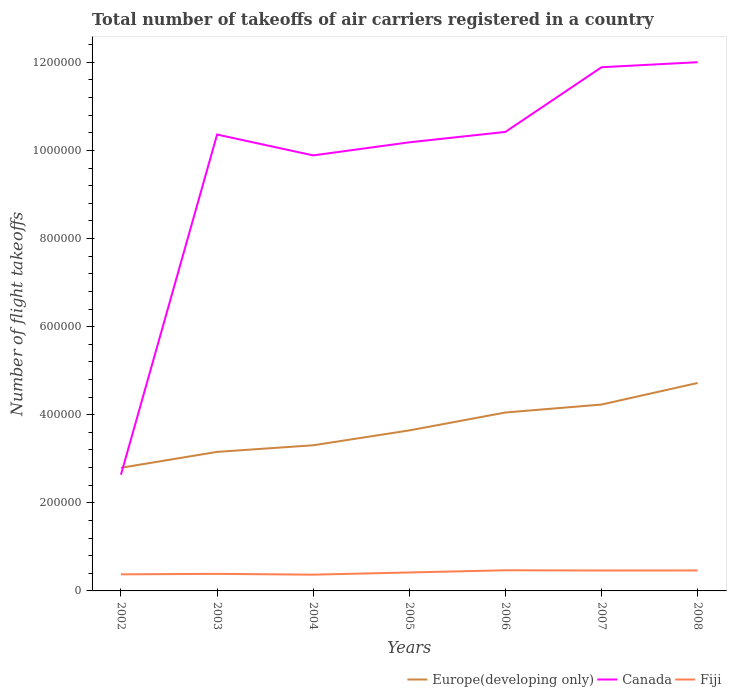How many different coloured lines are there?
Offer a terse response. 3. Is the number of lines equal to the number of legend labels?
Keep it short and to the point. Yes. Across all years, what is the maximum total number of flight takeoffs in Europe(developing only)?
Provide a short and direct response. 2.80e+05. In which year was the total number of flight takeoffs in Europe(developing only) maximum?
Ensure brevity in your answer.  2002. What is the total total number of flight takeoffs in Canada in the graph?
Provide a succinct answer. -1.82e+05. What is the difference between the highest and the second highest total number of flight takeoffs in Europe(developing only)?
Your answer should be very brief. 1.93e+05. What is the difference between the highest and the lowest total number of flight takeoffs in Fiji?
Your answer should be compact. 3. Is the total number of flight takeoffs in Canada strictly greater than the total number of flight takeoffs in Fiji over the years?
Provide a succinct answer. No. What is the difference between two consecutive major ticks on the Y-axis?
Make the answer very short. 2.00e+05. Are the values on the major ticks of Y-axis written in scientific E-notation?
Keep it short and to the point. No. Where does the legend appear in the graph?
Offer a very short reply. Bottom right. What is the title of the graph?
Give a very brief answer. Total number of takeoffs of air carriers registered in a country. Does "Congo (Democratic)" appear as one of the legend labels in the graph?
Offer a very short reply. No. What is the label or title of the Y-axis?
Provide a short and direct response. Number of flight takeoffs. What is the Number of flight takeoffs of Europe(developing only) in 2002?
Your answer should be very brief. 2.80e+05. What is the Number of flight takeoffs in Canada in 2002?
Ensure brevity in your answer.  2.64e+05. What is the Number of flight takeoffs in Fiji in 2002?
Provide a succinct answer. 3.77e+04. What is the Number of flight takeoffs of Europe(developing only) in 2003?
Provide a succinct answer. 3.16e+05. What is the Number of flight takeoffs of Canada in 2003?
Your answer should be compact. 1.04e+06. What is the Number of flight takeoffs of Fiji in 2003?
Your answer should be compact. 3.87e+04. What is the Number of flight takeoffs in Europe(developing only) in 2004?
Keep it short and to the point. 3.31e+05. What is the Number of flight takeoffs in Canada in 2004?
Keep it short and to the point. 9.89e+05. What is the Number of flight takeoffs in Fiji in 2004?
Provide a succinct answer. 3.69e+04. What is the Number of flight takeoffs in Europe(developing only) in 2005?
Keep it short and to the point. 3.64e+05. What is the Number of flight takeoffs of Canada in 2005?
Make the answer very short. 1.02e+06. What is the Number of flight takeoffs of Fiji in 2005?
Your response must be concise. 4.19e+04. What is the Number of flight takeoffs in Europe(developing only) in 2006?
Offer a terse response. 4.05e+05. What is the Number of flight takeoffs of Canada in 2006?
Make the answer very short. 1.04e+06. What is the Number of flight takeoffs in Fiji in 2006?
Provide a short and direct response. 4.69e+04. What is the Number of flight takeoffs of Europe(developing only) in 2007?
Give a very brief answer. 4.23e+05. What is the Number of flight takeoffs of Canada in 2007?
Your answer should be very brief. 1.19e+06. What is the Number of flight takeoffs of Fiji in 2007?
Your answer should be very brief. 4.64e+04. What is the Number of flight takeoffs in Europe(developing only) in 2008?
Keep it short and to the point. 4.72e+05. What is the Number of flight takeoffs in Canada in 2008?
Provide a short and direct response. 1.20e+06. What is the Number of flight takeoffs of Fiji in 2008?
Offer a very short reply. 4.65e+04. Across all years, what is the maximum Number of flight takeoffs in Europe(developing only)?
Offer a very short reply. 4.72e+05. Across all years, what is the maximum Number of flight takeoffs of Canada?
Your answer should be compact. 1.20e+06. Across all years, what is the maximum Number of flight takeoffs of Fiji?
Make the answer very short. 4.69e+04. Across all years, what is the minimum Number of flight takeoffs of Europe(developing only)?
Give a very brief answer. 2.80e+05. Across all years, what is the minimum Number of flight takeoffs in Canada?
Make the answer very short. 2.64e+05. Across all years, what is the minimum Number of flight takeoffs in Fiji?
Offer a very short reply. 3.69e+04. What is the total Number of flight takeoffs of Europe(developing only) in the graph?
Ensure brevity in your answer.  2.59e+06. What is the total Number of flight takeoffs in Canada in the graph?
Provide a short and direct response. 6.74e+06. What is the total Number of flight takeoffs in Fiji in the graph?
Give a very brief answer. 2.95e+05. What is the difference between the Number of flight takeoffs in Europe(developing only) in 2002 and that in 2003?
Keep it short and to the point. -3.61e+04. What is the difference between the Number of flight takeoffs of Canada in 2002 and that in 2003?
Your answer should be very brief. -7.72e+05. What is the difference between the Number of flight takeoffs in Fiji in 2002 and that in 2003?
Offer a very short reply. -1047. What is the difference between the Number of flight takeoffs of Europe(developing only) in 2002 and that in 2004?
Give a very brief answer. -5.11e+04. What is the difference between the Number of flight takeoffs of Canada in 2002 and that in 2004?
Offer a terse response. -7.25e+05. What is the difference between the Number of flight takeoffs in Fiji in 2002 and that in 2004?
Keep it short and to the point. 765. What is the difference between the Number of flight takeoffs of Europe(developing only) in 2002 and that in 2005?
Your answer should be compact. -8.49e+04. What is the difference between the Number of flight takeoffs in Canada in 2002 and that in 2005?
Offer a terse response. -7.55e+05. What is the difference between the Number of flight takeoffs of Fiji in 2002 and that in 2005?
Provide a succinct answer. -4201. What is the difference between the Number of flight takeoffs of Europe(developing only) in 2002 and that in 2006?
Provide a succinct answer. -1.26e+05. What is the difference between the Number of flight takeoffs of Canada in 2002 and that in 2006?
Provide a short and direct response. -7.78e+05. What is the difference between the Number of flight takeoffs in Fiji in 2002 and that in 2006?
Provide a short and direct response. -9181. What is the difference between the Number of flight takeoffs in Europe(developing only) in 2002 and that in 2007?
Provide a short and direct response. -1.44e+05. What is the difference between the Number of flight takeoffs of Canada in 2002 and that in 2007?
Offer a very short reply. -9.25e+05. What is the difference between the Number of flight takeoffs in Fiji in 2002 and that in 2007?
Make the answer very short. -8674. What is the difference between the Number of flight takeoffs of Europe(developing only) in 2002 and that in 2008?
Your answer should be very brief. -1.93e+05. What is the difference between the Number of flight takeoffs in Canada in 2002 and that in 2008?
Give a very brief answer. -9.36e+05. What is the difference between the Number of flight takeoffs of Fiji in 2002 and that in 2008?
Your answer should be very brief. -8782. What is the difference between the Number of flight takeoffs in Europe(developing only) in 2003 and that in 2004?
Offer a terse response. -1.50e+04. What is the difference between the Number of flight takeoffs in Canada in 2003 and that in 2004?
Offer a very short reply. 4.73e+04. What is the difference between the Number of flight takeoffs of Fiji in 2003 and that in 2004?
Your answer should be compact. 1812. What is the difference between the Number of flight takeoffs in Europe(developing only) in 2003 and that in 2005?
Make the answer very short. -4.87e+04. What is the difference between the Number of flight takeoffs of Canada in 2003 and that in 2005?
Provide a succinct answer. 1.76e+04. What is the difference between the Number of flight takeoffs of Fiji in 2003 and that in 2005?
Give a very brief answer. -3154. What is the difference between the Number of flight takeoffs in Europe(developing only) in 2003 and that in 2006?
Your response must be concise. -8.94e+04. What is the difference between the Number of flight takeoffs of Canada in 2003 and that in 2006?
Give a very brief answer. -6008. What is the difference between the Number of flight takeoffs in Fiji in 2003 and that in 2006?
Offer a very short reply. -8134. What is the difference between the Number of flight takeoffs of Europe(developing only) in 2003 and that in 2007?
Provide a short and direct response. -1.07e+05. What is the difference between the Number of flight takeoffs in Canada in 2003 and that in 2007?
Your response must be concise. -1.53e+05. What is the difference between the Number of flight takeoffs of Fiji in 2003 and that in 2007?
Offer a terse response. -7627. What is the difference between the Number of flight takeoffs in Europe(developing only) in 2003 and that in 2008?
Offer a terse response. -1.56e+05. What is the difference between the Number of flight takeoffs in Canada in 2003 and that in 2008?
Ensure brevity in your answer.  -1.64e+05. What is the difference between the Number of flight takeoffs in Fiji in 2003 and that in 2008?
Make the answer very short. -7735. What is the difference between the Number of flight takeoffs of Europe(developing only) in 2004 and that in 2005?
Make the answer very short. -3.38e+04. What is the difference between the Number of flight takeoffs in Canada in 2004 and that in 2005?
Make the answer very short. -2.97e+04. What is the difference between the Number of flight takeoffs of Fiji in 2004 and that in 2005?
Give a very brief answer. -4966. What is the difference between the Number of flight takeoffs of Europe(developing only) in 2004 and that in 2006?
Ensure brevity in your answer.  -7.44e+04. What is the difference between the Number of flight takeoffs of Canada in 2004 and that in 2006?
Offer a very short reply. -5.33e+04. What is the difference between the Number of flight takeoffs of Fiji in 2004 and that in 2006?
Offer a very short reply. -9946. What is the difference between the Number of flight takeoffs in Europe(developing only) in 2004 and that in 2007?
Your answer should be compact. -9.25e+04. What is the difference between the Number of flight takeoffs in Canada in 2004 and that in 2007?
Offer a very short reply. -2.00e+05. What is the difference between the Number of flight takeoffs of Fiji in 2004 and that in 2007?
Give a very brief answer. -9439. What is the difference between the Number of flight takeoffs of Europe(developing only) in 2004 and that in 2008?
Your answer should be compact. -1.41e+05. What is the difference between the Number of flight takeoffs in Canada in 2004 and that in 2008?
Your response must be concise. -2.12e+05. What is the difference between the Number of flight takeoffs of Fiji in 2004 and that in 2008?
Your response must be concise. -9547. What is the difference between the Number of flight takeoffs of Europe(developing only) in 2005 and that in 2006?
Provide a short and direct response. -4.07e+04. What is the difference between the Number of flight takeoffs in Canada in 2005 and that in 2006?
Provide a short and direct response. -2.36e+04. What is the difference between the Number of flight takeoffs in Fiji in 2005 and that in 2006?
Ensure brevity in your answer.  -4980. What is the difference between the Number of flight takeoffs of Europe(developing only) in 2005 and that in 2007?
Give a very brief answer. -5.87e+04. What is the difference between the Number of flight takeoffs of Canada in 2005 and that in 2007?
Your response must be concise. -1.70e+05. What is the difference between the Number of flight takeoffs of Fiji in 2005 and that in 2007?
Make the answer very short. -4473. What is the difference between the Number of flight takeoffs in Europe(developing only) in 2005 and that in 2008?
Ensure brevity in your answer.  -1.08e+05. What is the difference between the Number of flight takeoffs in Canada in 2005 and that in 2008?
Make the answer very short. -1.82e+05. What is the difference between the Number of flight takeoffs in Fiji in 2005 and that in 2008?
Keep it short and to the point. -4581. What is the difference between the Number of flight takeoffs of Europe(developing only) in 2006 and that in 2007?
Make the answer very short. -1.81e+04. What is the difference between the Number of flight takeoffs of Canada in 2006 and that in 2007?
Your answer should be compact. -1.47e+05. What is the difference between the Number of flight takeoffs of Fiji in 2006 and that in 2007?
Provide a short and direct response. 507. What is the difference between the Number of flight takeoffs in Europe(developing only) in 2006 and that in 2008?
Give a very brief answer. -6.70e+04. What is the difference between the Number of flight takeoffs of Canada in 2006 and that in 2008?
Provide a succinct answer. -1.58e+05. What is the difference between the Number of flight takeoffs in Fiji in 2006 and that in 2008?
Keep it short and to the point. 399. What is the difference between the Number of flight takeoffs of Europe(developing only) in 2007 and that in 2008?
Your response must be concise. -4.90e+04. What is the difference between the Number of flight takeoffs of Canada in 2007 and that in 2008?
Your answer should be compact. -1.14e+04. What is the difference between the Number of flight takeoffs in Fiji in 2007 and that in 2008?
Your answer should be compact. -108. What is the difference between the Number of flight takeoffs in Europe(developing only) in 2002 and the Number of flight takeoffs in Canada in 2003?
Your answer should be compact. -7.57e+05. What is the difference between the Number of flight takeoffs of Europe(developing only) in 2002 and the Number of flight takeoffs of Fiji in 2003?
Provide a short and direct response. 2.41e+05. What is the difference between the Number of flight takeoffs in Canada in 2002 and the Number of flight takeoffs in Fiji in 2003?
Offer a very short reply. 2.25e+05. What is the difference between the Number of flight takeoffs in Europe(developing only) in 2002 and the Number of flight takeoffs in Canada in 2004?
Provide a succinct answer. -7.09e+05. What is the difference between the Number of flight takeoffs of Europe(developing only) in 2002 and the Number of flight takeoffs of Fiji in 2004?
Your response must be concise. 2.43e+05. What is the difference between the Number of flight takeoffs in Canada in 2002 and the Number of flight takeoffs in Fiji in 2004?
Keep it short and to the point. 2.27e+05. What is the difference between the Number of flight takeoffs in Europe(developing only) in 2002 and the Number of flight takeoffs in Canada in 2005?
Your answer should be compact. -7.39e+05. What is the difference between the Number of flight takeoffs of Europe(developing only) in 2002 and the Number of flight takeoffs of Fiji in 2005?
Offer a very short reply. 2.38e+05. What is the difference between the Number of flight takeoffs of Canada in 2002 and the Number of flight takeoffs of Fiji in 2005?
Provide a succinct answer. 2.22e+05. What is the difference between the Number of flight takeoffs of Europe(developing only) in 2002 and the Number of flight takeoffs of Canada in 2006?
Your answer should be compact. -7.63e+05. What is the difference between the Number of flight takeoffs of Europe(developing only) in 2002 and the Number of flight takeoffs of Fiji in 2006?
Your answer should be compact. 2.33e+05. What is the difference between the Number of flight takeoffs in Canada in 2002 and the Number of flight takeoffs in Fiji in 2006?
Give a very brief answer. 2.17e+05. What is the difference between the Number of flight takeoffs in Europe(developing only) in 2002 and the Number of flight takeoffs in Canada in 2007?
Make the answer very short. -9.09e+05. What is the difference between the Number of flight takeoffs in Europe(developing only) in 2002 and the Number of flight takeoffs in Fiji in 2007?
Your answer should be compact. 2.33e+05. What is the difference between the Number of flight takeoffs of Canada in 2002 and the Number of flight takeoffs of Fiji in 2007?
Your response must be concise. 2.18e+05. What is the difference between the Number of flight takeoffs in Europe(developing only) in 2002 and the Number of flight takeoffs in Canada in 2008?
Keep it short and to the point. -9.21e+05. What is the difference between the Number of flight takeoffs of Europe(developing only) in 2002 and the Number of flight takeoffs of Fiji in 2008?
Offer a terse response. 2.33e+05. What is the difference between the Number of flight takeoffs of Canada in 2002 and the Number of flight takeoffs of Fiji in 2008?
Ensure brevity in your answer.  2.17e+05. What is the difference between the Number of flight takeoffs of Europe(developing only) in 2003 and the Number of flight takeoffs of Canada in 2004?
Give a very brief answer. -6.73e+05. What is the difference between the Number of flight takeoffs in Europe(developing only) in 2003 and the Number of flight takeoffs in Fiji in 2004?
Give a very brief answer. 2.79e+05. What is the difference between the Number of flight takeoffs in Canada in 2003 and the Number of flight takeoffs in Fiji in 2004?
Make the answer very short. 9.99e+05. What is the difference between the Number of flight takeoffs of Europe(developing only) in 2003 and the Number of flight takeoffs of Canada in 2005?
Provide a succinct answer. -7.03e+05. What is the difference between the Number of flight takeoffs of Europe(developing only) in 2003 and the Number of flight takeoffs of Fiji in 2005?
Your response must be concise. 2.74e+05. What is the difference between the Number of flight takeoffs in Canada in 2003 and the Number of flight takeoffs in Fiji in 2005?
Offer a terse response. 9.94e+05. What is the difference between the Number of flight takeoffs in Europe(developing only) in 2003 and the Number of flight takeoffs in Canada in 2006?
Your answer should be compact. -7.26e+05. What is the difference between the Number of flight takeoffs of Europe(developing only) in 2003 and the Number of flight takeoffs of Fiji in 2006?
Provide a short and direct response. 2.69e+05. What is the difference between the Number of flight takeoffs in Canada in 2003 and the Number of flight takeoffs in Fiji in 2006?
Ensure brevity in your answer.  9.89e+05. What is the difference between the Number of flight takeoffs of Europe(developing only) in 2003 and the Number of flight takeoffs of Canada in 2007?
Provide a short and direct response. -8.73e+05. What is the difference between the Number of flight takeoffs in Europe(developing only) in 2003 and the Number of flight takeoffs in Fiji in 2007?
Your response must be concise. 2.69e+05. What is the difference between the Number of flight takeoffs of Canada in 2003 and the Number of flight takeoffs of Fiji in 2007?
Your answer should be very brief. 9.90e+05. What is the difference between the Number of flight takeoffs of Europe(developing only) in 2003 and the Number of flight takeoffs of Canada in 2008?
Provide a succinct answer. -8.85e+05. What is the difference between the Number of flight takeoffs of Europe(developing only) in 2003 and the Number of flight takeoffs of Fiji in 2008?
Provide a short and direct response. 2.69e+05. What is the difference between the Number of flight takeoffs of Canada in 2003 and the Number of flight takeoffs of Fiji in 2008?
Give a very brief answer. 9.90e+05. What is the difference between the Number of flight takeoffs in Europe(developing only) in 2004 and the Number of flight takeoffs in Canada in 2005?
Make the answer very short. -6.88e+05. What is the difference between the Number of flight takeoffs of Europe(developing only) in 2004 and the Number of flight takeoffs of Fiji in 2005?
Provide a short and direct response. 2.89e+05. What is the difference between the Number of flight takeoffs of Canada in 2004 and the Number of flight takeoffs of Fiji in 2005?
Ensure brevity in your answer.  9.47e+05. What is the difference between the Number of flight takeoffs of Europe(developing only) in 2004 and the Number of flight takeoffs of Canada in 2006?
Give a very brief answer. -7.11e+05. What is the difference between the Number of flight takeoffs in Europe(developing only) in 2004 and the Number of flight takeoffs in Fiji in 2006?
Give a very brief answer. 2.84e+05. What is the difference between the Number of flight takeoffs of Canada in 2004 and the Number of flight takeoffs of Fiji in 2006?
Your answer should be very brief. 9.42e+05. What is the difference between the Number of flight takeoffs of Europe(developing only) in 2004 and the Number of flight takeoffs of Canada in 2007?
Provide a succinct answer. -8.58e+05. What is the difference between the Number of flight takeoffs of Europe(developing only) in 2004 and the Number of flight takeoffs of Fiji in 2007?
Offer a terse response. 2.84e+05. What is the difference between the Number of flight takeoffs of Canada in 2004 and the Number of flight takeoffs of Fiji in 2007?
Provide a succinct answer. 9.42e+05. What is the difference between the Number of flight takeoffs of Europe(developing only) in 2004 and the Number of flight takeoffs of Canada in 2008?
Ensure brevity in your answer.  -8.70e+05. What is the difference between the Number of flight takeoffs of Europe(developing only) in 2004 and the Number of flight takeoffs of Fiji in 2008?
Offer a terse response. 2.84e+05. What is the difference between the Number of flight takeoffs of Canada in 2004 and the Number of flight takeoffs of Fiji in 2008?
Your answer should be very brief. 9.42e+05. What is the difference between the Number of flight takeoffs in Europe(developing only) in 2005 and the Number of flight takeoffs in Canada in 2006?
Offer a very short reply. -6.78e+05. What is the difference between the Number of flight takeoffs in Europe(developing only) in 2005 and the Number of flight takeoffs in Fiji in 2006?
Offer a terse response. 3.18e+05. What is the difference between the Number of flight takeoffs of Canada in 2005 and the Number of flight takeoffs of Fiji in 2006?
Your answer should be very brief. 9.72e+05. What is the difference between the Number of flight takeoffs of Europe(developing only) in 2005 and the Number of flight takeoffs of Canada in 2007?
Offer a terse response. -8.25e+05. What is the difference between the Number of flight takeoffs of Europe(developing only) in 2005 and the Number of flight takeoffs of Fiji in 2007?
Ensure brevity in your answer.  3.18e+05. What is the difference between the Number of flight takeoffs of Canada in 2005 and the Number of flight takeoffs of Fiji in 2007?
Provide a short and direct response. 9.72e+05. What is the difference between the Number of flight takeoffs of Europe(developing only) in 2005 and the Number of flight takeoffs of Canada in 2008?
Your answer should be very brief. -8.36e+05. What is the difference between the Number of flight takeoffs of Europe(developing only) in 2005 and the Number of flight takeoffs of Fiji in 2008?
Your answer should be very brief. 3.18e+05. What is the difference between the Number of flight takeoffs in Canada in 2005 and the Number of flight takeoffs in Fiji in 2008?
Your answer should be very brief. 9.72e+05. What is the difference between the Number of flight takeoffs in Europe(developing only) in 2006 and the Number of flight takeoffs in Canada in 2007?
Your answer should be compact. -7.84e+05. What is the difference between the Number of flight takeoffs of Europe(developing only) in 2006 and the Number of flight takeoffs of Fiji in 2007?
Make the answer very short. 3.59e+05. What is the difference between the Number of flight takeoffs in Canada in 2006 and the Number of flight takeoffs in Fiji in 2007?
Offer a terse response. 9.96e+05. What is the difference between the Number of flight takeoffs in Europe(developing only) in 2006 and the Number of flight takeoffs in Canada in 2008?
Offer a very short reply. -7.95e+05. What is the difference between the Number of flight takeoffs of Europe(developing only) in 2006 and the Number of flight takeoffs of Fiji in 2008?
Offer a very short reply. 3.59e+05. What is the difference between the Number of flight takeoffs in Canada in 2006 and the Number of flight takeoffs in Fiji in 2008?
Make the answer very short. 9.96e+05. What is the difference between the Number of flight takeoffs of Europe(developing only) in 2007 and the Number of flight takeoffs of Canada in 2008?
Your answer should be very brief. -7.77e+05. What is the difference between the Number of flight takeoffs in Europe(developing only) in 2007 and the Number of flight takeoffs in Fiji in 2008?
Ensure brevity in your answer.  3.77e+05. What is the difference between the Number of flight takeoffs in Canada in 2007 and the Number of flight takeoffs in Fiji in 2008?
Your response must be concise. 1.14e+06. What is the average Number of flight takeoffs in Europe(developing only) per year?
Make the answer very short. 3.70e+05. What is the average Number of flight takeoffs in Canada per year?
Provide a succinct answer. 9.63e+05. What is the average Number of flight takeoffs of Fiji per year?
Your answer should be very brief. 4.21e+04. In the year 2002, what is the difference between the Number of flight takeoffs of Europe(developing only) and Number of flight takeoffs of Canada?
Your response must be concise. 1.56e+04. In the year 2002, what is the difference between the Number of flight takeoffs of Europe(developing only) and Number of flight takeoffs of Fiji?
Give a very brief answer. 2.42e+05. In the year 2002, what is the difference between the Number of flight takeoffs in Canada and Number of flight takeoffs in Fiji?
Give a very brief answer. 2.26e+05. In the year 2003, what is the difference between the Number of flight takeoffs of Europe(developing only) and Number of flight takeoffs of Canada?
Keep it short and to the point. -7.20e+05. In the year 2003, what is the difference between the Number of flight takeoffs of Europe(developing only) and Number of flight takeoffs of Fiji?
Provide a succinct answer. 2.77e+05. In the year 2003, what is the difference between the Number of flight takeoffs of Canada and Number of flight takeoffs of Fiji?
Provide a succinct answer. 9.97e+05. In the year 2004, what is the difference between the Number of flight takeoffs in Europe(developing only) and Number of flight takeoffs in Canada?
Offer a very short reply. -6.58e+05. In the year 2004, what is the difference between the Number of flight takeoffs of Europe(developing only) and Number of flight takeoffs of Fiji?
Provide a short and direct response. 2.94e+05. In the year 2004, what is the difference between the Number of flight takeoffs of Canada and Number of flight takeoffs of Fiji?
Offer a very short reply. 9.52e+05. In the year 2005, what is the difference between the Number of flight takeoffs of Europe(developing only) and Number of flight takeoffs of Canada?
Give a very brief answer. -6.54e+05. In the year 2005, what is the difference between the Number of flight takeoffs in Europe(developing only) and Number of flight takeoffs in Fiji?
Keep it short and to the point. 3.23e+05. In the year 2005, what is the difference between the Number of flight takeoffs of Canada and Number of flight takeoffs of Fiji?
Ensure brevity in your answer.  9.77e+05. In the year 2006, what is the difference between the Number of flight takeoffs in Europe(developing only) and Number of flight takeoffs in Canada?
Keep it short and to the point. -6.37e+05. In the year 2006, what is the difference between the Number of flight takeoffs in Europe(developing only) and Number of flight takeoffs in Fiji?
Your response must be concise. 3.58e+05. In the year 2006, what is the difference between the Number of flight takeoffs of Canada and Number of flight takeoffs of Fiji?
Your answer should be compact. 9.95e+05. In the year 2007, what is the difference between the Number of flight takeoffs of Europe(developing only) and Number of flight takeoffs of Canada?
Provide a succinct answer. -7.66e+05. In the year 2007, what is the difference between the Number of flight takeoffs of Europe(developing only) and Number of flight takeoffs of Fiji?
Ensure brevity in your answer.  3.77e+05. In the year 2007, what is the difference between the Number of flight takeoffs in Canada and Number of flight takeoffs in Fiji?
Keep it short and to the point. 1.14e+06. In the year 2008, what is the difference between the Number of flight takeoffs of Europe(developing only) and Number of flight takeoffs of Canada?
Provide a short and direct response. -7.28e+05. In the year 2008, what is the difference between the Number of flight takeoffs in Europe(developing only) and Number of flight takeoffs in Fiji?
Make the answer very short. 4.26e+05. In the year 2008, what is the difference between the Number of flight takeoffs of Canada and Number of flight takeoffs of Fiji?
Your response must be concise. 1.15e+06. What is the ratio of the Number of flight takeoffs in Europe(developing only) in 2002 to that in 2003?
Your answer should be compact. 0.89. What is the ratio of the Number of flight takeoffs of Canada in 2002 to that in 2003?
Your response must be concise. 0.25. What is the ratio of the Number of flight takeoffs in Europe(developing only) in 2002 to that in 2004?
Ensure brevity in your answer.  0.85. What is the ratio of the Number of flight takeoffs in Canada in 2002 to that in 2004?
Offer a terse response. 0.27. What is the ratio of the Number of flight takeoffs of Fiji in 2002 to that in 2004?
Offer a very short reply. 1.02. What is the ratio of the Number of flight takeoffs in Europe(developing only) in 2002 to that in 2005?
Make the answer very short. 0.77. What is the ratio of the Number of flight takeoffs of Canada in 2002 to that in 2005?
Your answer should be very brief. 0.26. What is the ratio of the Number of flight takeoffs of Fiji in 2002 to that in 2005?
Provide a short and direct response. 0.9. What is the ratio of the Number of flight takeoffs of Europe(developing only) in 2002 to that in 2006?
Your answer should be compact. 0.69. What is the ratio of the Number of flight takeoffs in Canada in 2002 to that in 2006?
Your response must be concise. 0.25. What is the ratio of the Number of flight takeoffs in Fiji in 2002 to that in 2006?
Make the answer very short. 0.8. What is the ratio of the Number of flight takeoffs in Europe(developing only) in 2002 to that in 2007?
Offer a very short reply. 0.66. What is the ratio of the Number of flight takeoffs of Canada in 2002 to that in 2007?
Offer a terse response. 0.22. What is the ratio of the Number of flight takeoffs of Fiji in 2002 to that in 2007?
Offer a terse response. 0.81. What is the ratio of the Number of flight takeoffs in Europe(developing only) in 2002 to that in 2008?
Provide a succinct answer. 0.59. What is the ratio of the Number of flight takeoffs in Canada in 2002 to that in 2008?
Offer a very short reply. 0.22. What is the ratio of the Number of flight takeoffs of Fiji in 2002 to that in 2008?
Ensure brevity in your answer.  0.81. What is the ratio of the Number of flight takeoffs of Europe(developing only) in 2003 to that in 2004?
Provide a short and direct response. 0.95. What is the ratio of the Number of flight takeoffs in Canada in 2003 to that in 2004?
Ensure brevity in your answer.  1.05. What is the ratio of the Number of flight takeoffs of Fiji in 2003 to that in 2004?
Give a very brief answer. 1.05. What is the ratio of the Number of flight takeoffs of Europe(developing only) in 2003 to that in 2005?
Your answer should be compact. 0.87. What is the ratio of the Number of flight takeoffs of Canada in 2003 to that in 2005?
Provide a succinct answer. 1.02. What is the ratio of the Number of flight takeoffs of Fiji in 2003 to that in 2005?
Your response must be concise. 0.92. What is the ratio of the Number of flight takeoffs in Europe(developing only) in 2003 to that in 2006?
Ensure brevity in your answer.  0.78. What is the ratio of the Number of flight takeoffs of Fiji in 2003 to that in 2006?
Offer a very short reply. 0.83. What is the ratio of the Number of flight takeoffs of Europe(developing only) in 2003 to that in 2007?
Provide a succinct answer. 0.75. What is the ratio of the Number of flight takeoffs of Canada in 2003 to that in 2007?
Keep it short and to the point. 0.87. What is the ratio of the Number of flight takeoffs of Fiji in 2003 to that in 2007?
Provide a short and direct response. 0.84. What is the ratio of the Number of flight takeoffs in Europe(developing only) in 2003 to that in 2008?
Your answer should be very brief. 0.67. What is the ratio of the Number of flight takeoffs of Canada in 2003 to that in 2008?
Offer a terse response. 0.86. What is the ratio of the Number of flight takeoffs of Fiji in 2003 to that in 2008?
Offer a very short reply. 0.83. What is the ratio of the Number of flight takeoffs of Europe(developing only) in 2004 to that in 2005?
Keep it short and to the point. 0.91. What is the ratio of the Number of flight takeoffs in Canada in 2004 to that in 2005?
Keep it short and to the point. 0.97. What is the ratio of the Number of flight takeoffs of Fiji in 2004 to that in 2005?
Ensure brevity in your answer.  0.88. What is the ratio of the Number of flight takeoffs of Europe(developing only) in 2004 to that in 2006?
Offer a terse response. 0.82. What is the ratio of the Number of flight takeoffs of Canada in 2004 to that in 2006?
Provide a succinct answer. 0.95. What is the ratio of the Number of flight takeoffs in Fiji in 2004 to that in 2006?
Make the answer very short. 0.79. What is the ratio of the Number of flight takeoffs in Europe(developing only) in 2004 to that in 2007?
Offer a very short reply. 0.78. What is the ratio of the Number of flight takeoffs of Canada in 2004 to that in 2007?
Your response must be concise. 0.83. What is the ratio of the Number of flight takeoffs in Fiji in 2004 to that in 2007?
Your answer should be very brief. 0.8. What is the ratio of the Number of flight takeoffs in Europe(developing only) in 2004 to that in 2008?
Provide a short and direct response. 0.7. What is the ratio of the Number of flight takeoffs in Canada in 2004 to that in 2008?
Offer a very short reply. 0.82. What is the ratio of the Number of flight takeoffs in Fiji in 2004 to that in 2008?
Your answer should be compact. 0.79. What is the ratio of the Number of flight takeoffs in Europe(developing only) in 2005 to that in 2006?
Your response must be concise. 0.9. What is the ratio of the Number of flight takeoffs of Canada in 2005 to that in 2006?
Keep it short and to the point. 0.98. What is the ratio of the Number of flight takeoffs of Fiji in 2005 to that in 2006?
Your answer should be compact. 0.89. What is the ratio of the Number of flight takeoffs of Europe(developing only) in 2005 to that in 2007?
Offer a terse response. 0.86. What is the ratio of the Number of flight takeoffs of Canada in 2005 to that in 2007?
Your answer should be compact. 0.86. What is the ratio of the Number of flight takeoffs in Fiji in 2005 to that in 2007?
Ensure brevity in your answer.  0.9. What is the ratio of the Number of flight takeoffs in Europe(developing only) in 2005 to that in 2008?
Ensure brevity in your answer.  0.77. What is the ratio of the Number of flight takeoffs in Canada in 2005 to that in 2008?
Your response must be concise. 0.85. What is the ratio of the Number of flight takeoffs in Fiji in 2005 to that in 2008?
Make the answer very short. 0.9. What is the ratio of the Number of flight takeoffs of Europe(developing only) in 2006 to that in 2007?
Your answer should be very brief. 0.96. What is the ratio of the Number of flight takeoffs of Canada in 2006 to that in 2007?
Offer a very short reply. 0.88. What is the ratio of the Number of flight takeoffs in Fiji in 2006 to that in 2007?
Your response must be concise. 1.01. What is the ratio of the Number of flight takeoffs of Europe(developing only) in 2006 to that in 2008?
Your response must be concise. 0.86. What is the ratio of the Number of flight takeoffs of Canada in 2006 to that in 2008?
Give a very brief answer. 0.87. What is the ratio of the Number of flight takeoffs in Fiji in 2006 to that in 2008?
Make the answer very short. 1.01. What is the ratio of the Number of flight takeoffs of Europe(developing only) in 2007 to that in 2008?
Keep it short and to the point. 0.9. What is the difference between the highest and the second highest Number of flight takeoffs in Europe(developing only)?
Your answer should be very brief. 4.90e+04. What is the difference between the highest and the second highest Number of flight takeoffs in Canada?
Provide a short and direct response. 1.14e+04. What is the difference between the highest and the second highest Number of flight takeoffs of Fiji?
Provide a succinct answer. 399. What is the difference between the highest and the lowest Number of flight takeoffs of Europe(developing only)?
Make the answer very short. 1.93e+05. What is the difference between the highest and the lowest Number of flight takeoffs in Canada?
Offer a very short reply. 9.36e+05. What is the difference between the highest and the lowest Number of flight takeoffs in Fiji?
Offer a terse response. 9946. 